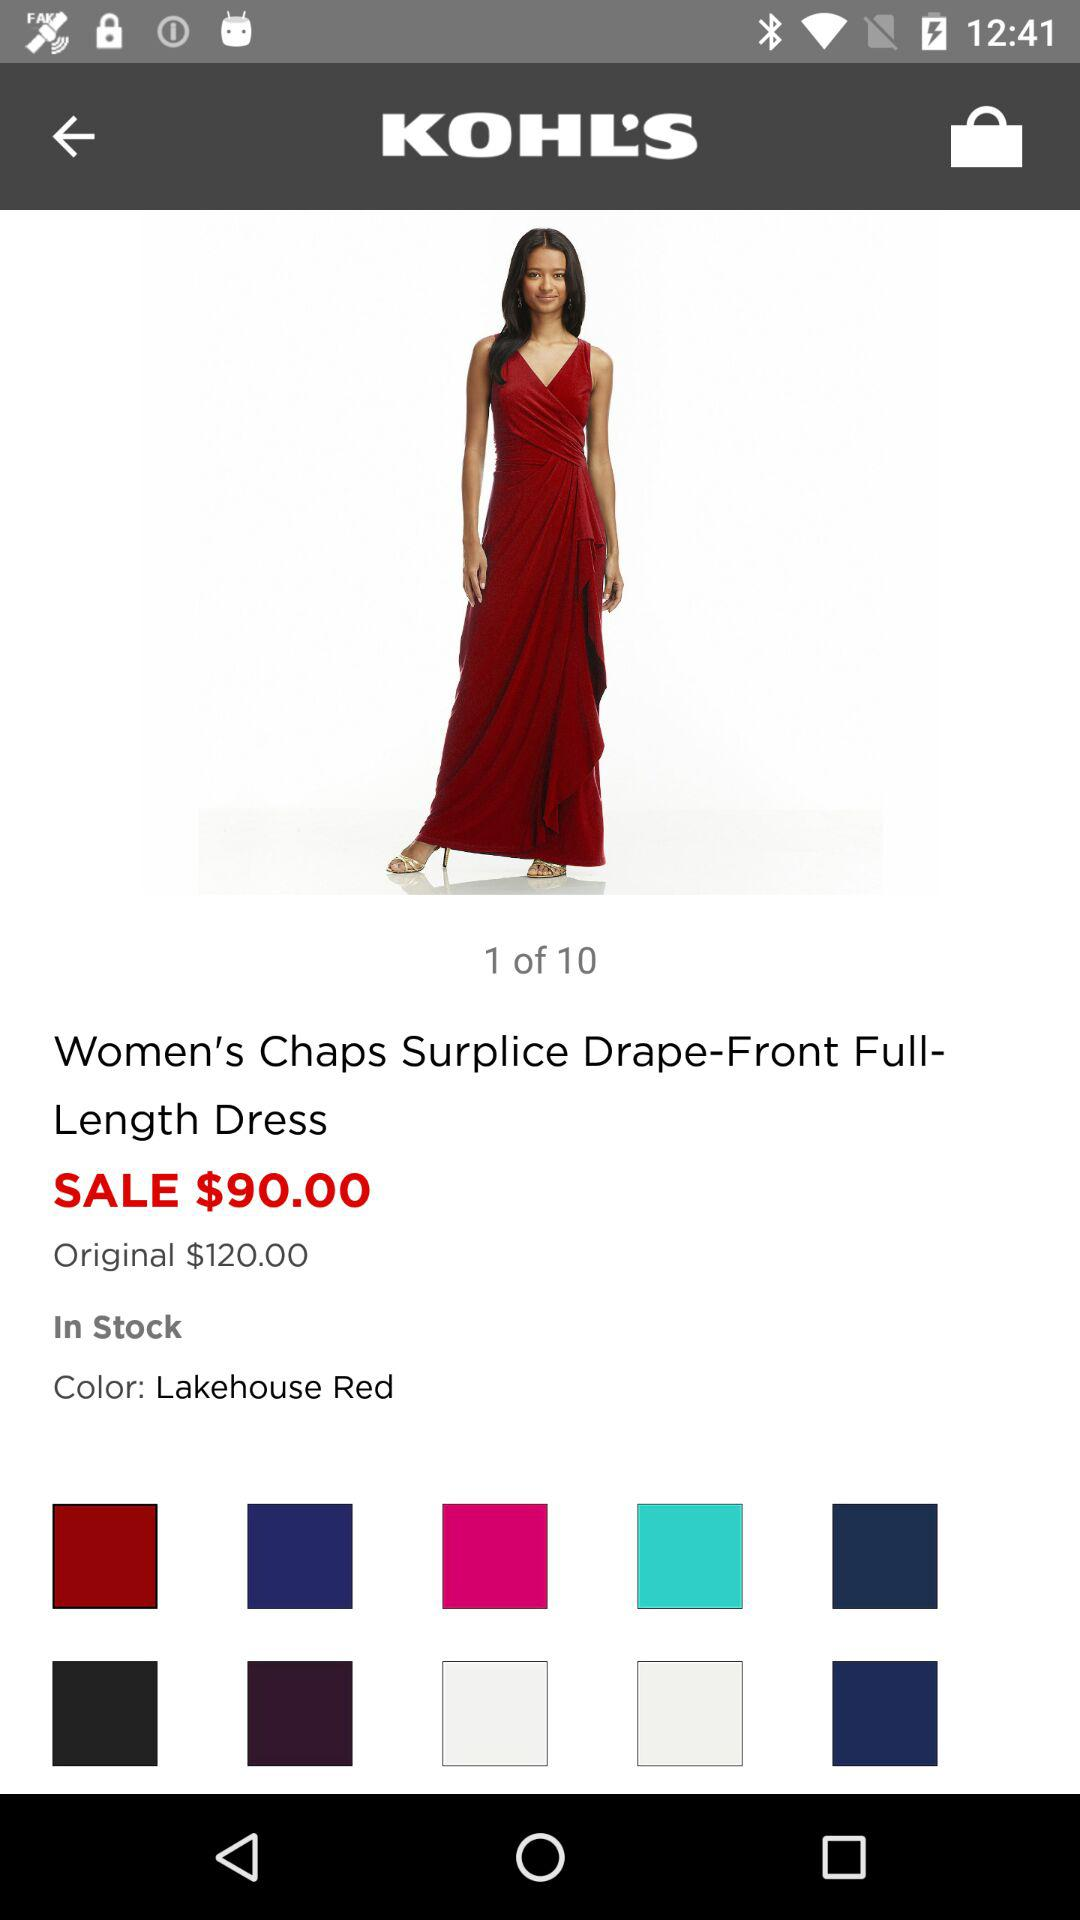How much is the original price of the dress?
Answer the question using a single word or phrase. $120.00 